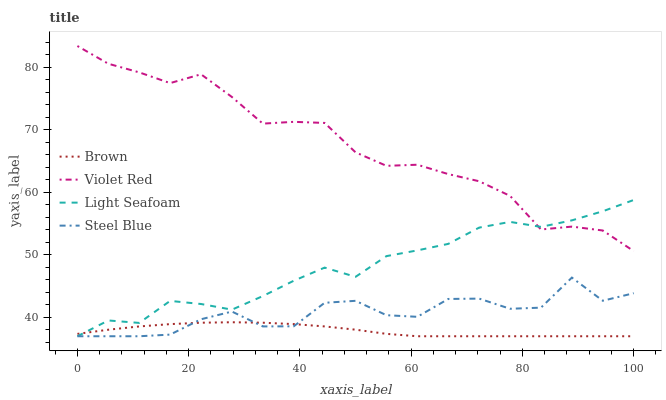Does Light Seafoam have the minimum area under the curve?
Answer yes or no. No. Does Light Seafoam have the maximum area under the curve?
Answer yes or no. No. Is Violet Red the smoothest?
Answer yes or no. No. Is Violet Red the roughest?
Answer yes or no. No. Does Violet Red have the lowest value?
Answer yes or no. No. Does Light Seafoam have the highest value?
Answer yes or no. No. Is Steel Blue less than Violet Red?
Answer yes or no. Yes. Is Violet Red greater than Brown?
Answer yes or no. Yes. Does Steel Blue intersect Violet Red?
Answer yes or no. No. 